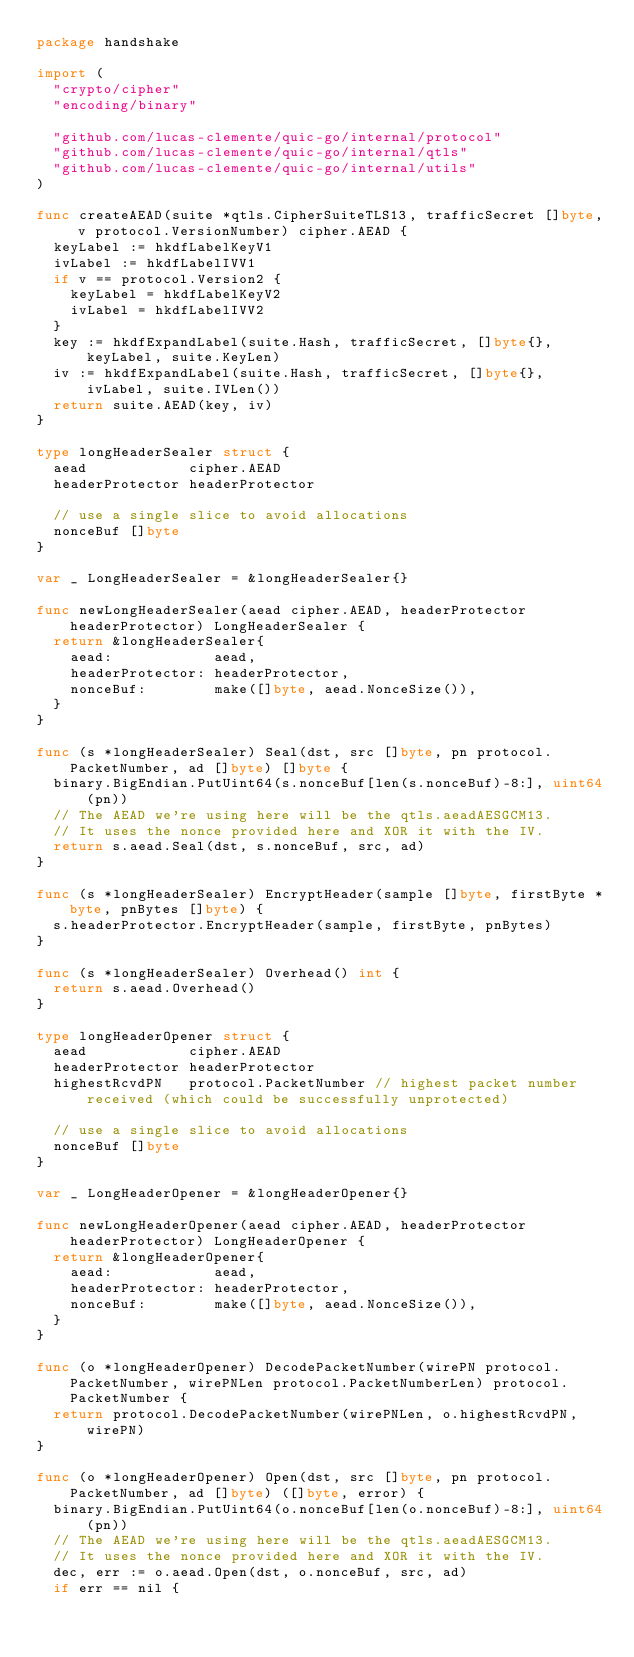Convert code to text. <code><loc_0><loc_0><loc_500><loc_500><_Go_>package handshake

import (
	"crypto/cipher"
	"encoding/binary"

	"github.com/lucas-clemente/quic-go/internal/protocol"
	"github.com/lucas-clemente/quic-go/internal/qtls"
	"github.com/lucas-clemente/quic-go/internal/utils"
)

func createAEAD(suite *qtls.CipherSuiteTLS13, trafficSecret []byte, v protocol.VersionNumber) cipher.AEAD {
	keyLabel := hkdfLabelKeyV1
	ivLabel := hkdfLabelIVV1
	if v == protocol.Version2 {
		keyLabel = hkdfLabelKeyV2
		ivLabel = hkdfLabelIVV2
	}
	key := hkdfExpandLabel(suite.Hash, trafficSecret, []byte{}, keyLabel, suite.KeyLen)
	iv := hkdfExpandLabel(suite.Hash, trafficSecret, []byte{}, ivLabel, suite.IVLen())
	return suite.AEAD(key, iv)
}

type longHeaderSealer struct {
	aead            cipher.AEAD
	headerProtector headerProtector

	// use a single slice to avoid allocations
	nonceBuf []byte
}

var _ LongHeaderSealer = &longHeaderSealer{}

func newLongHeaderSealer(aead cipher.AEAD, headerProtector headerProtector) LongHeaderSealer {
	return &longHeaderSealer{
		aead:            aead,
		headerProtector: headerProtector,
		nonceBuf:        make([]byte, aead.NonceSize()),
	}
}

func (s *longHeaderSealer) Seal(dst, src []byte, pn protocol.PacketNumber, ad []byte) []byte {
	binary.BigEndian.PutUint64(s.nonceBuf[len(s.nonceBuf)-8:], uint64(pn))
	// The AEAD we're using here will be the qtls.aeadAESGCM13.
	// It uses the nonce provided here and XOR it with the IV.
	return s.aead.Seal(dst, s.nonceBuf, src, ad)
}

func (s *longHeaderSealer) EncryptHeader(sample []byte, firstByte *byte, pnBytes []byte) {
	s.headerProtector.EncryptHeader(sample, firstByte, pnBytes)
}

func (s *longHeaderSealer) Overhead() int {
	return s.aead.Overhead()
}

type longHeaderOpener struct {
	aead            cipher.AEAD
	headerProtector headerProtector
	highestRcvdPN   protocol.PacketNumber // highest packet number received (which could be successfully unprotected)

	// use a single slice to avoid allocations
	nonceBuf []byte
}

var _ LongHeaderOpener = &longHeaderOpener{}

func newLongHeaderOpener(aead cipher.AEAD, headerProtector headerProtector) LongHeaderOpener {
	return &longHeaderOpener{
		aead:            aead,
		headerProtector: headerProtector,
		nonceBuf:        make([]byte, aead.NonceSize()),
	}
}

func (o *longHeaderOpener) DecodePacketNumber(wirePN protocol.PacketNumber, wirePNLen protocol.PacketNumberLen) protocol.PacketNumber {
	return protocol.DecodePacketNumber(wirePNLen, o.highestRcvdPN, wirePN)
}

func (o *longHeaderOpener) Open(dst, src []byte, pn protocol.PacketNumber, ad []byte) ([]byte, error) {
	binary.BigEndian.PutUint64(o.nonceBuf[len(o.nonceBuf)-8:], uint64(pn))
	// The AEAD we're using here will be the qtls.aeadAESGCM13.
	// It uses the nonce provided here and XOR it with the IV.
	dec, err := o.aead.Open(dst, o.nonceBuf, src, ad)
	if err == nil {</code> 